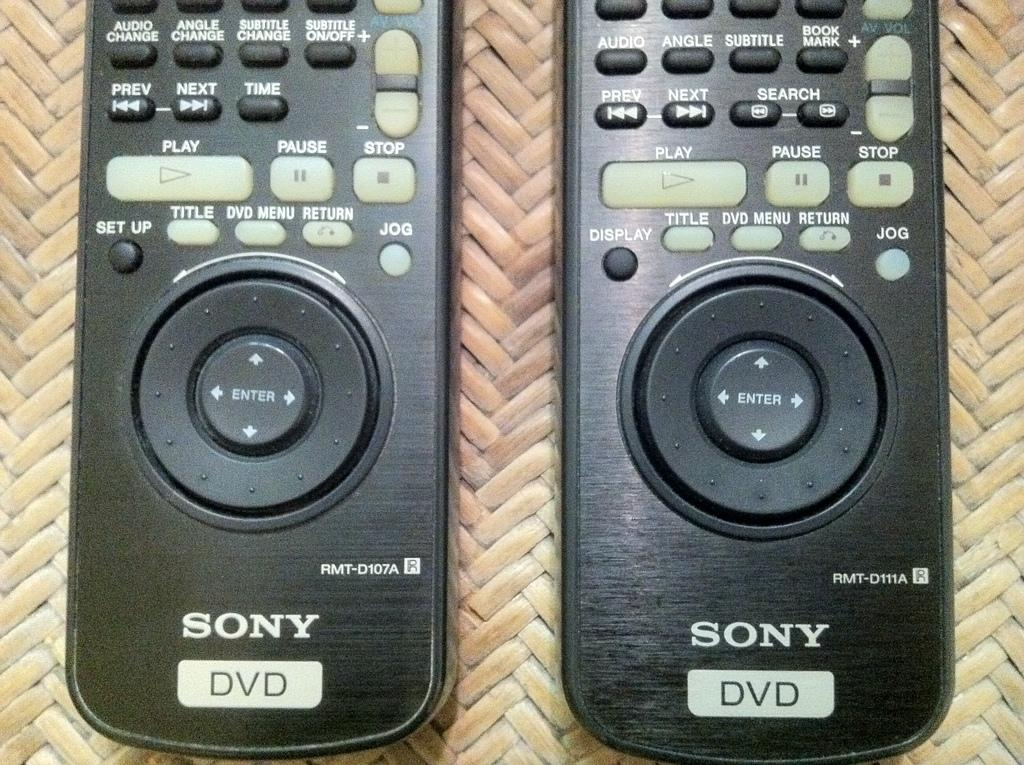<image>
Render a clear and concise summary of the photo. two black sony dvd remotes side by side. 